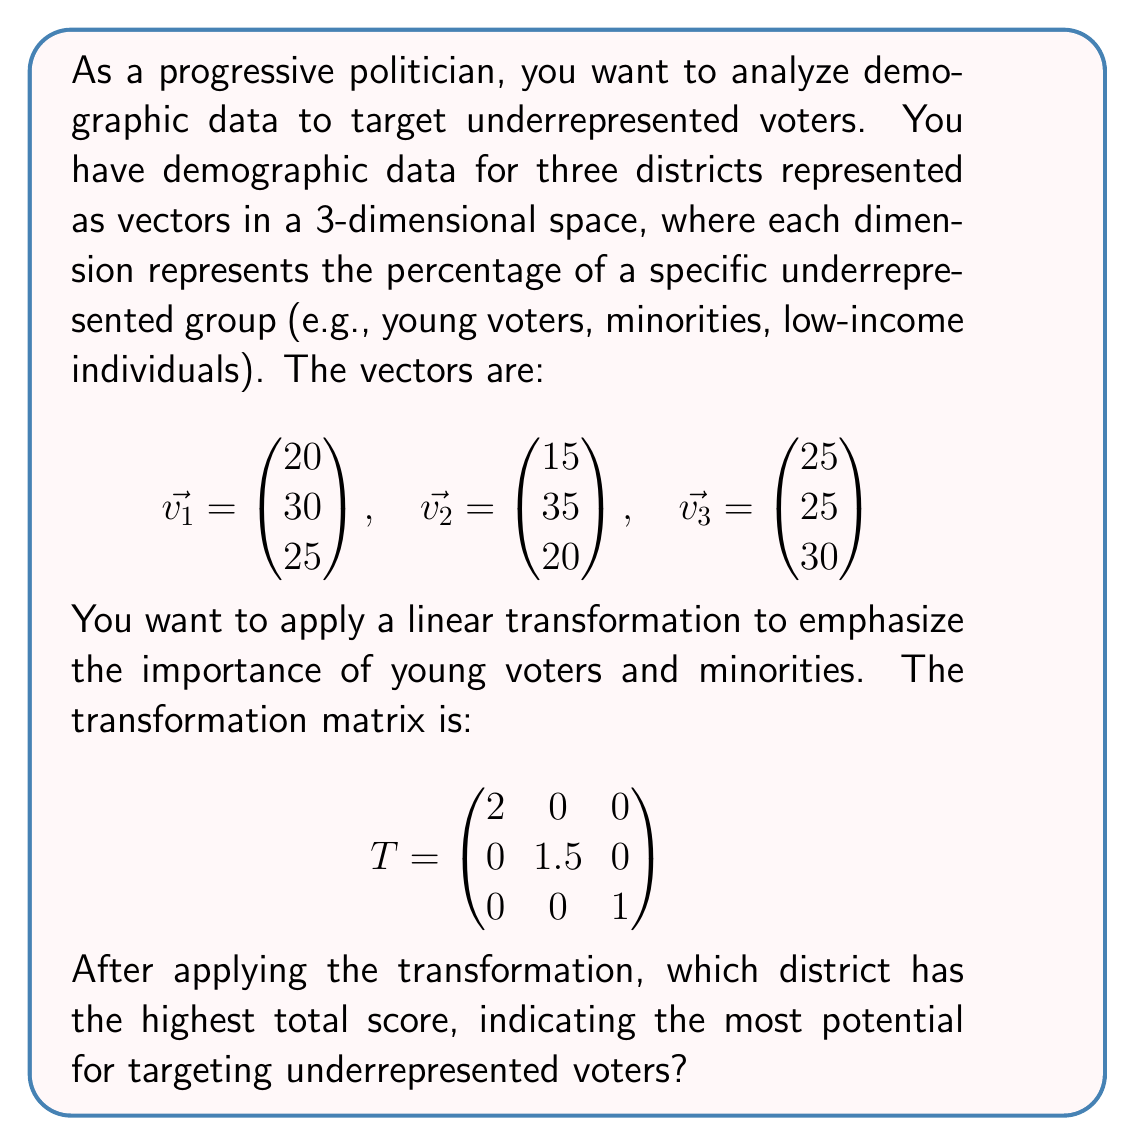Could you help me with this problem? To solve this problem, we need to apply the linear transformation to each vector and then calculate the sum of the components for each transformed vector. The district with the highest sum will be our target.

Step 1: Apply the transformation to each vector
For each vector $\vec{v_i}$, we calculate $T\vec{v_i}$:

For $\vec{v_1}$:
$$T\vec{v_1} = \begin{pmatrix} 2 & 0 & 0 \\ 0 & 1.5 & 0 \\ 0 & 0 & 1 \end{pmatrix} \begin{pmatrix} 20 \\ 30 \\ 25 \end{pmatrix} = \begin{pmatrix} 40 \\ 45 \\ 25 \end{pmatrix}$$

For $\vec{v_2}$:
$$T\vec{v_2} = \begin{pmatrix} 2 & 0 & 0 \\ 0 & 1.5 & 0 \\ 0 & 0 & 1 \end{pmatrix} \begin{pmatrix} 15 \\ 35 \\ 20 \end{pmatrix} = \begin{pmatrix} 30 \\ 52.5 \\ 20 \end{pmatrix}$$

For $\vec{v_3}$:
$$T\vec{v_3} = \begin{pmatrix} 2 & 0 & 0 \\ 0 & 1.5 & 0 \\ 0 & 0 & 1 \end{pmatrix} \begin{pmatrix} 25 \\ 25 \\ 30 \end{pmatrix} = \begin{pmatrix} 50 \\ 37.5 \\ 30 \end{pmatrix}$$

Step 2: Calculate the sum of components for each transformed vector

For $T\vec{v_1}$: $40 + 45 + 25 = 110$
For $T\vec{v_2}$: $30 + 52.5 + 20 = 102.5$
For $T\vec{v_3}$: $50 + 37.5 + 30 = 117.5$

Step 3: Compare the sums

The highest sum is 117.5, which corresponds to the transformed vector $T\vec{v_3}$.
Answer: District 3 